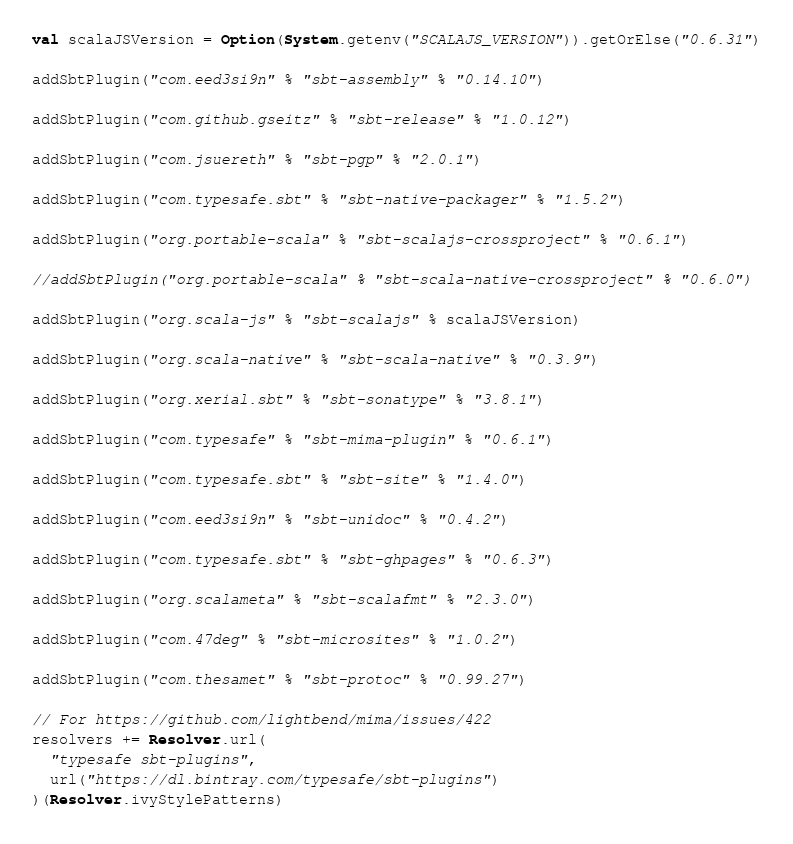Convert code to text. <code><loc_0><loc_0><loc_500><loc_500><_Scala_>val scalaJSVersion = Option(System.getenv("SCALAJS_VERSION")).getOrElse("0.6.31")

addSbtPlugin("com.eed3si9n" % "sbt-assembly" % "0.14.10")

addSbtPlugin("com.github.gseitz" % "sbt-release" % "1.0.12")

addSbtPlugin("com.jsuereth" % "sbt-pgp" % "2.0.1")

addSbtPlugin("com.typesafe.sbt" % "sbt-native-packager" % "1.5.2")

addSbtPlugin("org.portable-scala" % "sbt-scalajs-crossproject" % "0.6.1")

//addSbtPlugin("org.portable-scala" % "sbt-scala-native-crossproject" % "0.6.0")

addSbtPlugin("org.scala-js" % "sbt-scalajs" % scalaJSVersion)

addSbtPlugin("org.scala-native" % "sbt-scala-native" % "0.3.9")

addSbtPlugin("org.xerial.sbt" % "sbt-sonatype" % "3.8.1")

addSbtPlugin("com.typesafe" % "sbt-mima-plugin" % "0.6.1")

addSbtPlugin("com.typesafe.sbt" % "sbt-site" % "1.4.0")

addSbtPlugin("com.eed3si9n" % "sbt-unidoc" % "0.4.2")

addSbtPlugin("com.typesafe.sbt" % "sbt-ghpages" % "0.6.3")

addSbtPlugin("org.scalameta" % "sbt-scalafmt" % "2.3.0")

addSbtPlugin("com.47deg" % "sbt-microsites" % "1.0.2")

addSbtPlugin("com.thesamet" % "sbt-protoc" % "0.99.27")

// For https://github.com/lightbend/mima/issues/422
resolvers += Resolver.url(
  "typesafe sbt-plugins",
  url("https://dl.bintray.com/typesafe/sbt-plugins")
)(Resolver.ivyStylePatterns)
</code> 